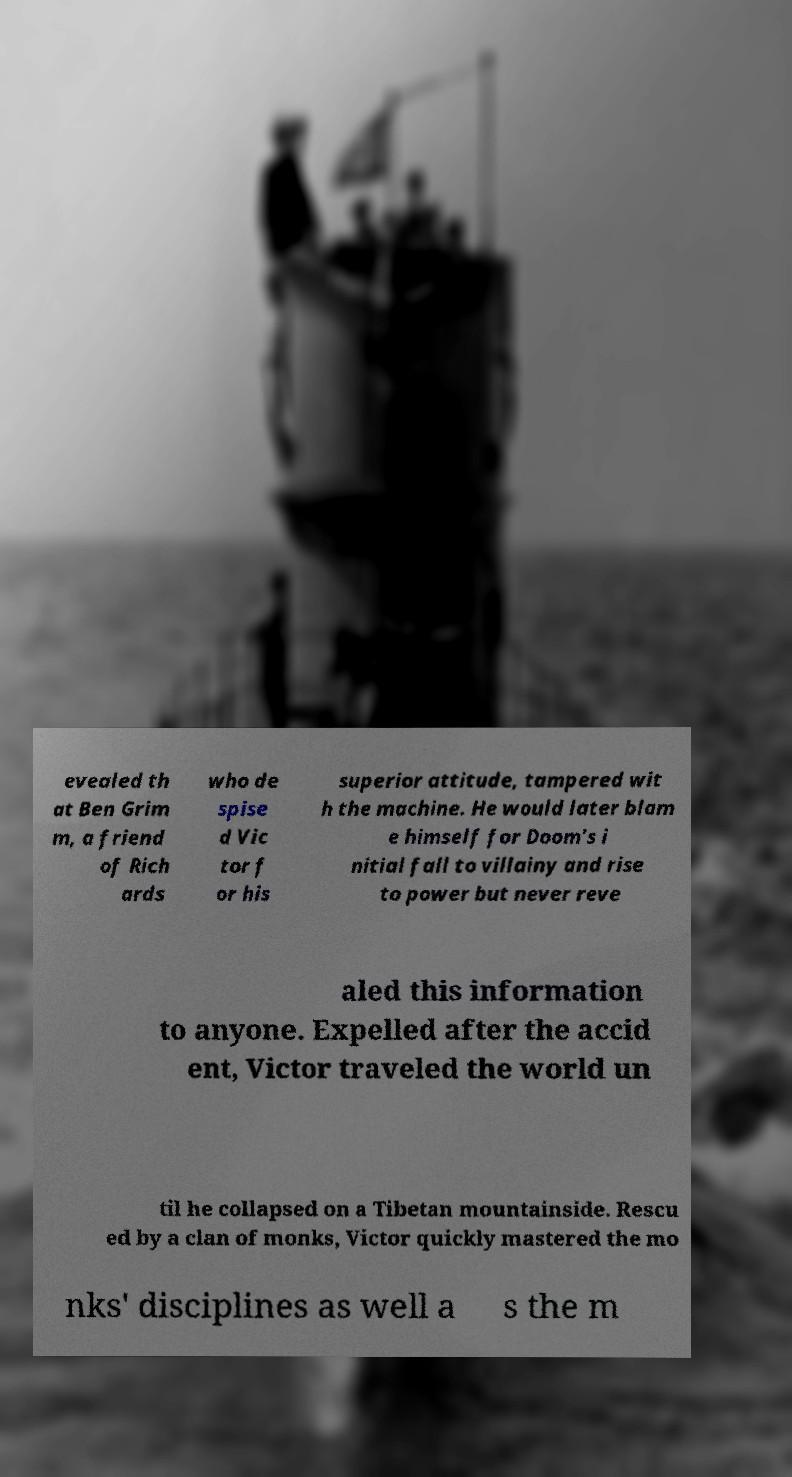Please identify and transcribe the text found in this image. evealed th at Ben Grim m, a friend of Rich ards who de spise d Vic tor f or his superior attitude, tampered wit h the machine. He would later blam e himself for Doom's i nitial fall to villainy and rise to power but never reve aled this information to anyone. Expelled after the accid ent, Victor traveled the world un til he collapsed on a Tibetan mountainside. Rescu ed by a clan of monks, Victor quickly mastered the mo nks' disciplines as well a s the m 